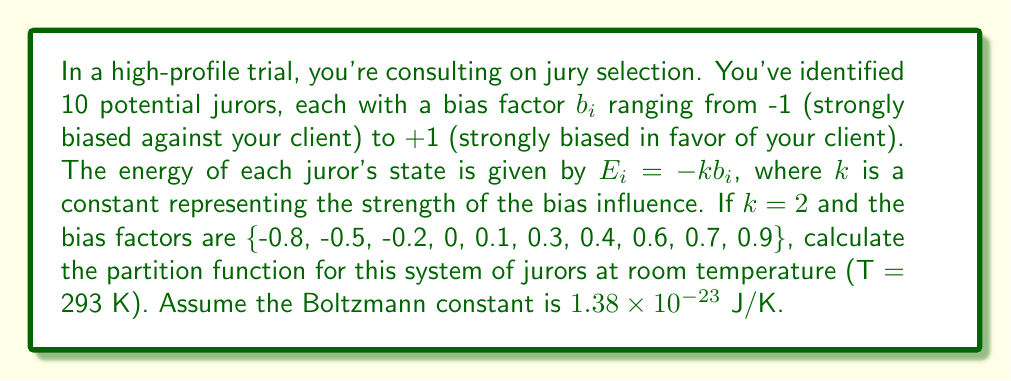Teach me how to tackle this problem. To solve this problem, we'll follow these steps:

1) The partition function Z is given by:

   $$Z = \sum_{i=1}^N e^{-\beta E_i}$$

   where $\beta = \frac{1}{k_B T}$, $k_B$ is the Boltzmann constant, and T is the temperature.

2) Calculate $\beta$:
   $$\beta = \frac{1}{(1.38 \times 10^{-23} \text{ J/K})(293 \text{ K})} = 2.47 \times 10^{20} \text{ J}^{-1}$$

3) For each juror, calculate $E_i = -kb_i$:
   $E_1 = -2(-0.8) = 1.6$ J
   $E_2 = -2(-0.5) = 1.0$ J
   $E_3 = -2(-0.2) = 0.4$ J
   $E_4 = -2(0) = 0$ J
   $E_5 = -2(0.1) = -0.2$ J
   $E_6 = -2(0.3) = -0.6$ J
   $E_7 = -2(0.4) = -0.8$ J
   $E_8 = -2(0.6) = -1.2$ J
   $E_9 = -2(0.7) = -1.4$ J
   $E_{10} = -2(0.9) = -1.8$ J

4) Calculate $e^{-\beta E_i}$ for each juror:
   $e^{-\beta E_1} = e^{-(2.47 \times 10^{20})(1.6)} = e^{-3.95 \times 10^{20}}$
   $e^{-\beta E_2} = e^{-(2.47 \times 10^{20})(1.0)} = e^{-2.47 \times 10^{20}}$
   $e^{-\beta E_3} = e^{-(2.47 \times 10^{20})(0.4)} = e^{-9.88 \times 10^{19}}$
   $e^{-\beta E_4} = e^{-(2.47 \times 10^{20})(0)} = 1$
   $e^{-\beta E_5} = e^{-(2.47 \times 10^{20})(-0.2)} = e^{4.94 \times 10^{19}}$
   $e^{-\beta E_6} = e^{-(2.47 \times 10^{20})(-0.6)} = e^{1.48 \times 10^{20}}$
   $e^{-\beta E_7} = e^{-(2.47 \times 10^{20})(-0.8)} = e^{1.98 \times 10^{20}}$
   $e^{-\beta E_8} = e^{-(2.47 \times 10^{20})(-1.2)} = e^{2.96 \times 10^{20}}$
   $e^{-\beta E_9} = e^{-(2.47 \times 10^{20})(-1.4)} = e^{3.46 \times 10^{20}}$
   $e^{-\beta E_{10}} = e^{-(2.47 \times 10^{20})(-1.8)} = e^{4.45 \times 10^{20}}$

5) Sum all these terms to get Z:

   $$Z = e^{-3.95 \times 10^{20}} + e^{-2.47 \times 10^{20}} + e^{-9.88 \times 10^{19}} + 1 + e^{4.94 \times 10^{19}} + e^{1.48 \times 10^{20}} + e^{1.98 \times 10^{20}} + e^{2.96 \times 10^{20}} + e^{3.46 \times 10^{20}} + e^{4.45 \times 10^{20}}$$

6) The terms with negative exponents are extremely small and can be neglected. The term with the largest positive exponent dominates:

   $$Z \approx e^{4.45 \times 10^{20}}$$
Answer: $Z \approx e^{4.45 \times 10^{20}}$ 